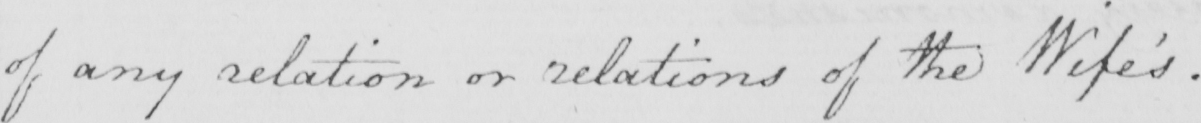What does this handwritten line say? of any relation or relations of the Wife ' s . 